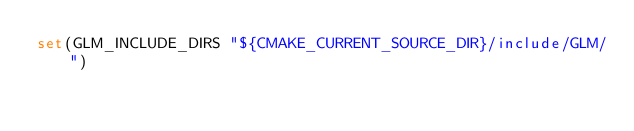Convert code to text. <code><loc_0><loc_0><loc_500><loc_500><_CMake_>set(GLM_INCLUDE_DIRS "${CMAKE_CURRENT_SOURCE_DIR}/include/GLM/")
</code> 